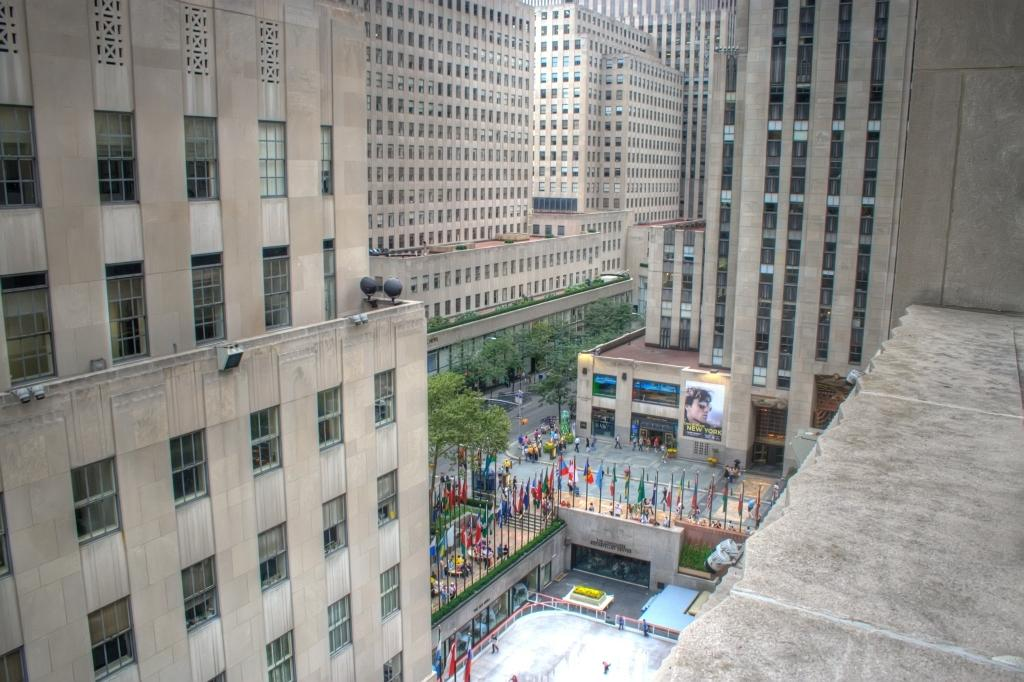What type of structures can be seen in the image? There are buildings in the image. What is located in the middle of the image? There are flags in the middle of the image. Can you identify any living beings in the image? Yes, there are people visible in the image. What type of natural elements can be seen in the image? There are trees in the image. What type of scissors can be seen cutting the trees in the image? There are no scissors or tree-cutting activity present in the image. How does the temper of the people affect the image? The temper of the people cannot be determined from the image, as it does not show their emotions or expressions. 